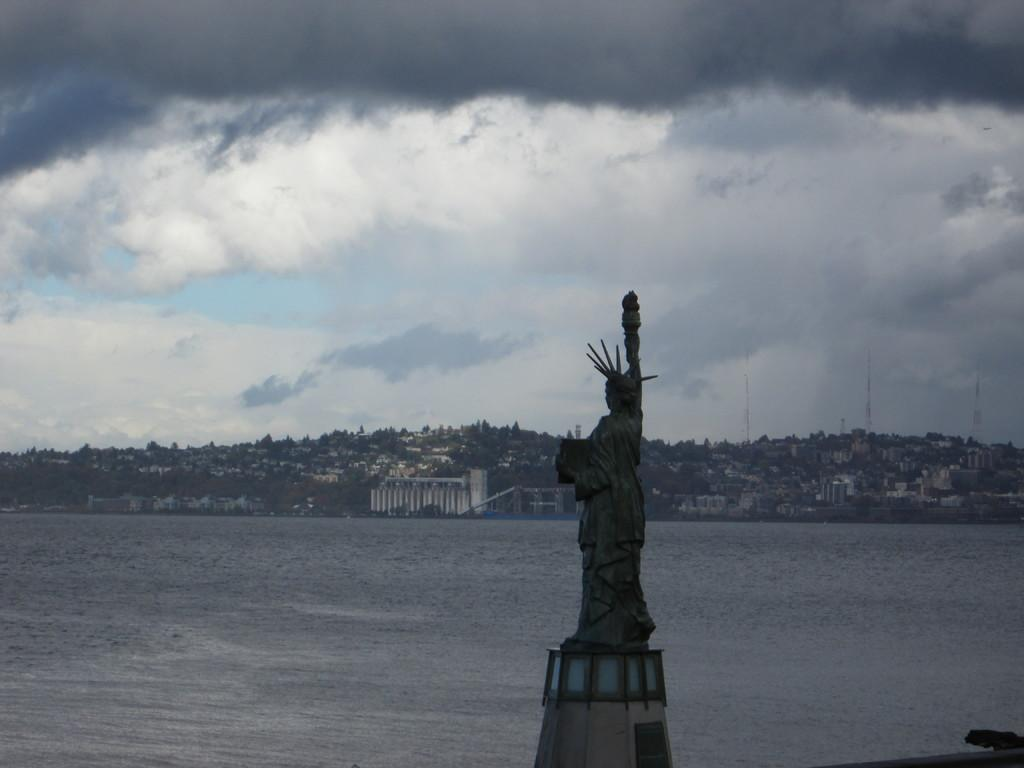What is the main subject of the image? The main subject of the image is a statue. What natural feature can be seen in the image? There is a river visible in the image. What type of structures can be seen in the background of the image? There are buildings in the background of the image. What is visible at the top of the image? The sky is visible at the top of the image. What can be observed in the sky? Clouds are present in the sky. What type of love can be seen in the image? There is no love present in the image; it features a statue, a river, buildings, and clouds in the sky. Can you tell me how many cubs are visible in the image? There are no cubs present in the image. 